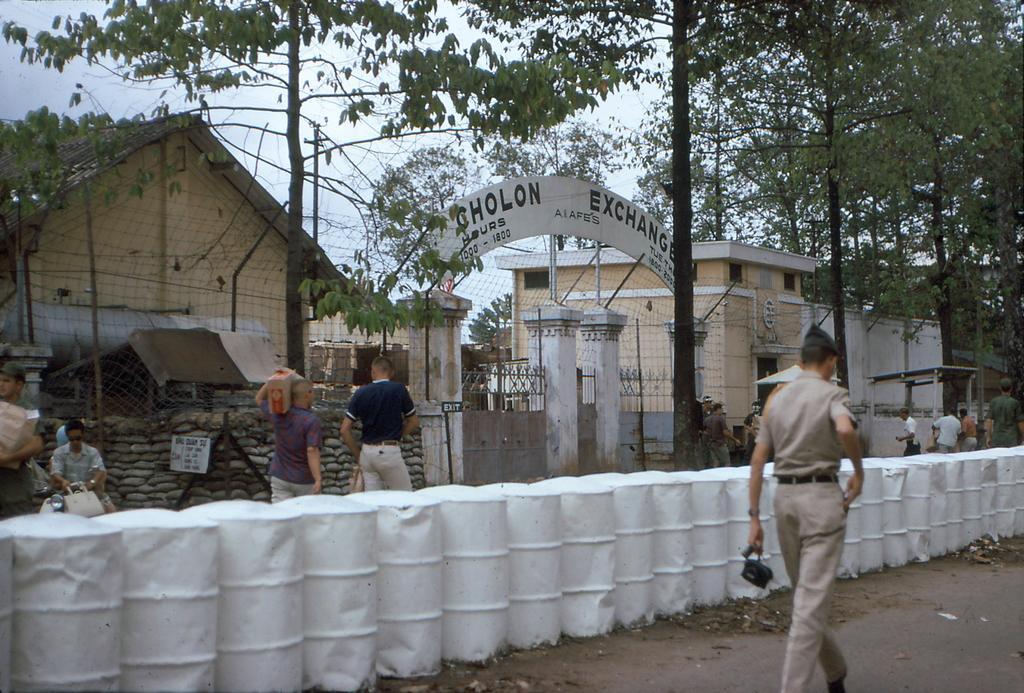Please provide a concise description of this image. To the right side of the image there is a person walking wearing a uniform. At the bottom of the image there is road. There are white color drums. In the background of the image there is a gate with a arch with some text on it. There are trees. There is fencing. there are people walking. To the right side of the image there is a house. 